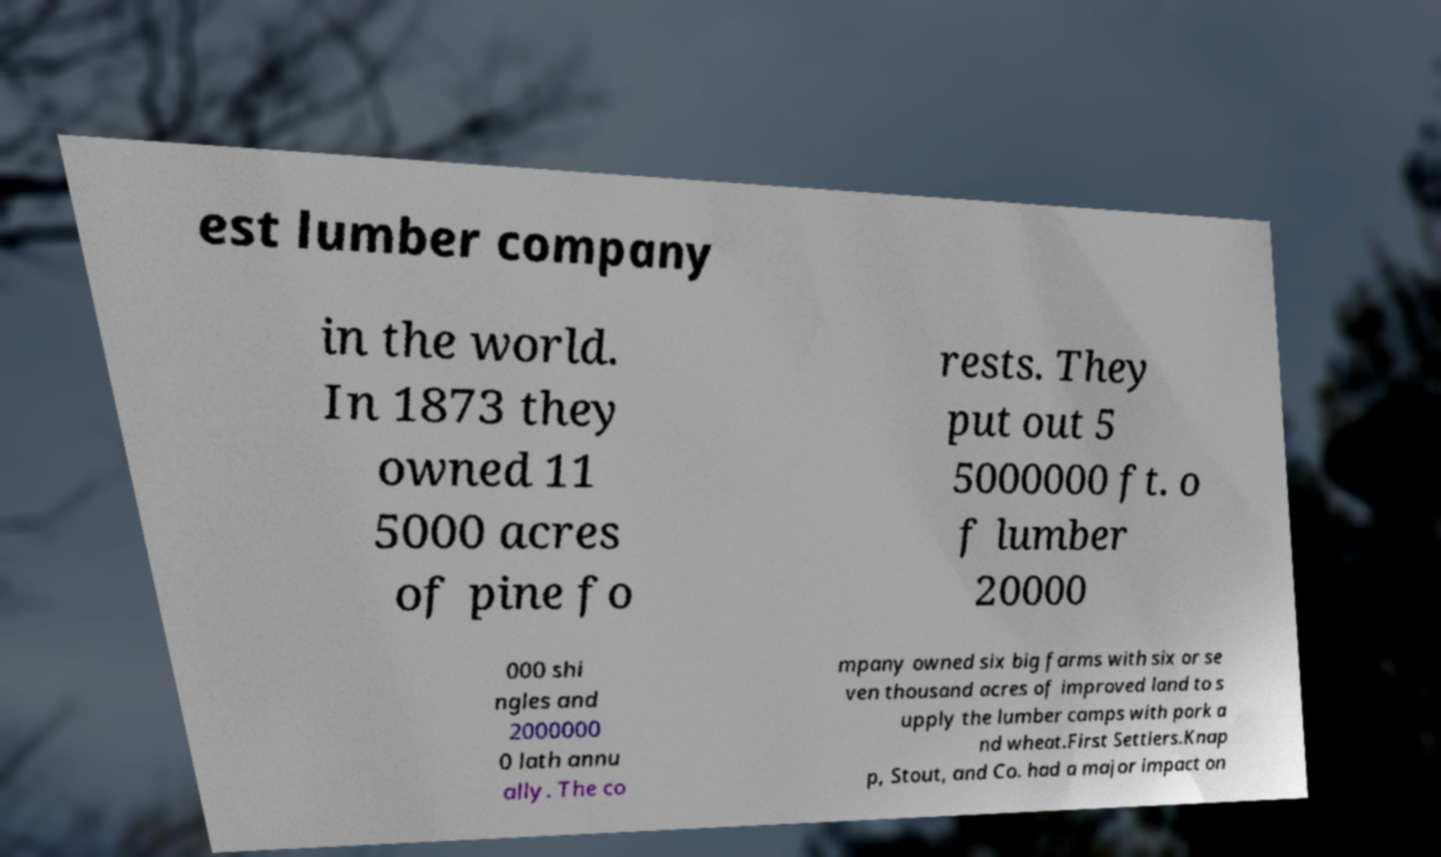Can you accurately transcribe the text from the provided image for me? est lumber company in the world. In 1873 they owned 11 5000 acres of pine fo rests. They put out 5 5000000 ft. o f lumber 20000 000 shi ngles and 2000000 0 lath annu ally. The co mpany owned six big farms with six or se ven thousand acres of improved land to s upply the lumber camps with pork a nd wheat.First Settlers.Knap p, Stout, and Co. had a major impact on 